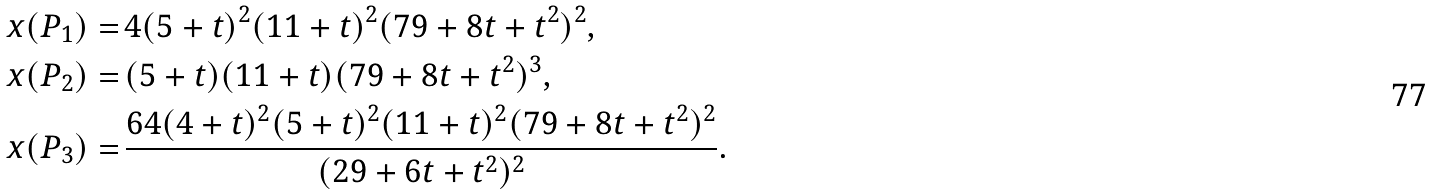<formula> <loc_0><loc_0><loc_500><loc_500>x ( P _ { 1 } ) = & \, 4 ( 5 + t ) ^ { 2 } ( 1 1 + t ) ^ { 2 } ( 7 9 + 8 t + t ^ { 2 } ) ^ { 2 } , \\ x ( P _ { 2 } ) = & \, ( 5 + t ) ( 1 1 + t ) ( 7 9 + 8 t + t ^ { 2 } ) ^ { 3 } , \\ x ( P _ { 3 } ) = & \, \frac { 6 4 ( 4 + t ) ^ { 2 } ( 5 + t ) ^ { 2 } ( 1 1 + t ) ^ { 2 } ( 7 9 + 8 t + t ^ { 2 } ) ^ { 2 } } { ( 2 9 + 6 t + t ^ { 2 } ) ^ { 2 } } .</formula> 